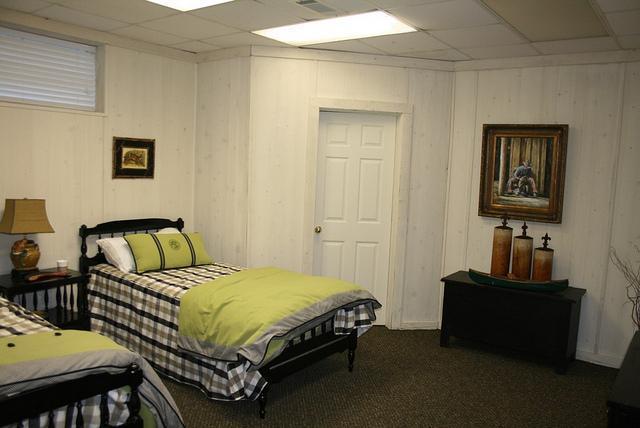How many beds are there?
Give a very brief answer. 2. How many clock are seen?
Give a very brief answer. 0. 